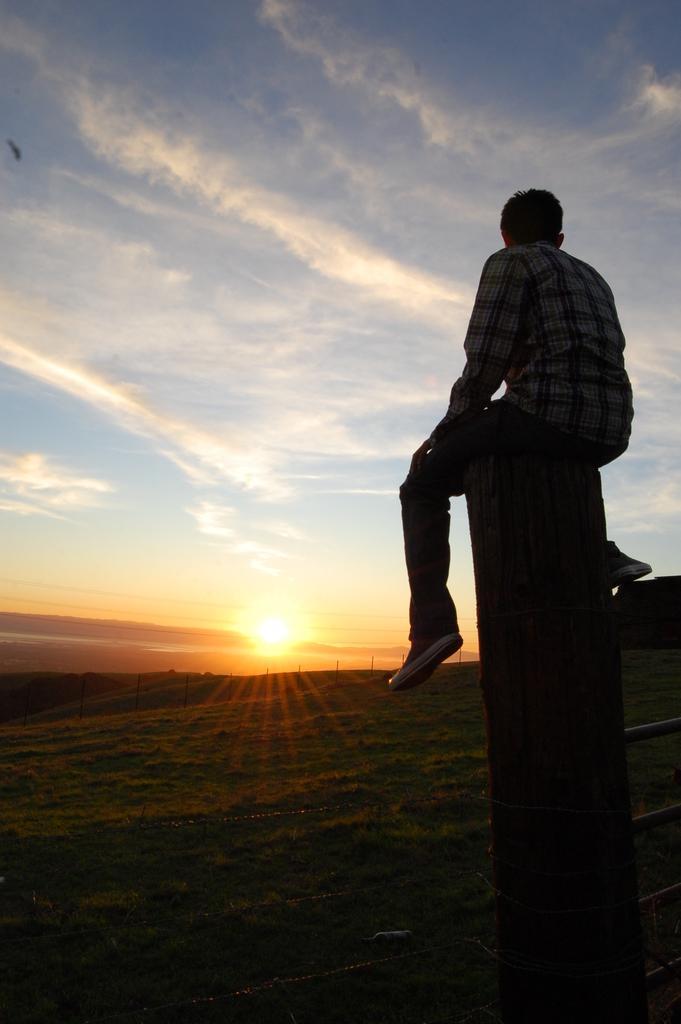Can you describe this image briefly? This image consists of a man sitting on the pillar. On the right, we can see a railing. At the bottom, there is a ground. In the background, we can see the sun in the sky along with the clouds. 